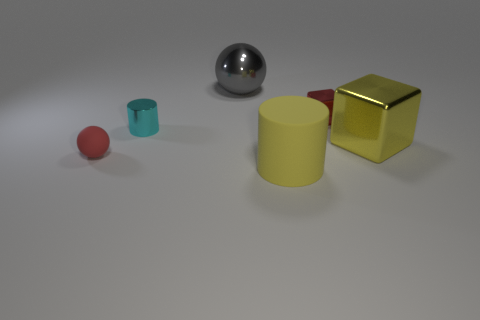Subtract all yellow cylinders. How many cylinders are left? 1 Subtract all spheres. How many objects are left? 4 Add 1 big rubber things. How many objects exist? 7 Add 6 large blue rubber spheres. How many large blue rubber spheres exist? 6 Subtract 0 yellow balls. How many objects are left? 6 Subtract all cyan cylinders. Subtract all red blocks. How many cylinders are left? 1 Subtract all blue spheres. How many red cylinders are left? 0 Subtract all yellow things. Subtract all yellow rubber objects. How many objects are left? 3 Add 2 red shiny objects. How many red shiny objects are left? 3 